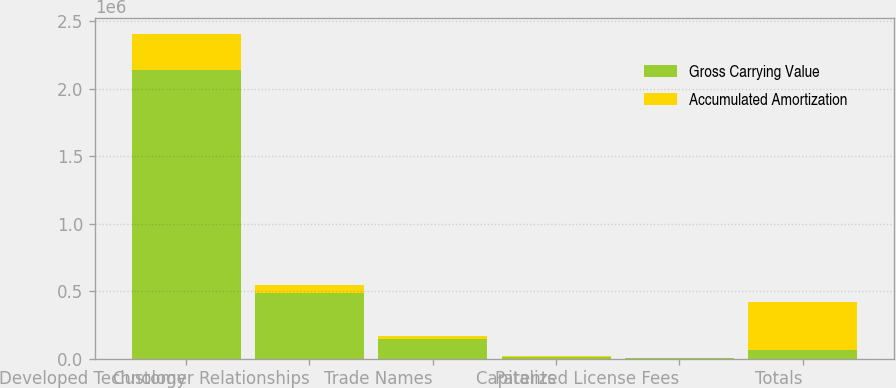<chart> <loc_0><loc_0><loc_500><loc_500><stacked_bar_chart><ecel><fcel>Developed Technology<fcel>Customer Relationships<fcel>Trade Names<fcel>Patents<fcel>Capitalized License Fees<fcel>Totals<nl><fcel>Gross Carrying Value<fcel>2.13771e+06<fcel>484993<fcel>146965<fcel>11513<fcel>2766<fcel>63494<nl><fcel>Accumulated Amortization<fcel>267259<fcel>63494<fcel>20094<fcel>7771<fcel>518<fcel>359136<nl></chart> 